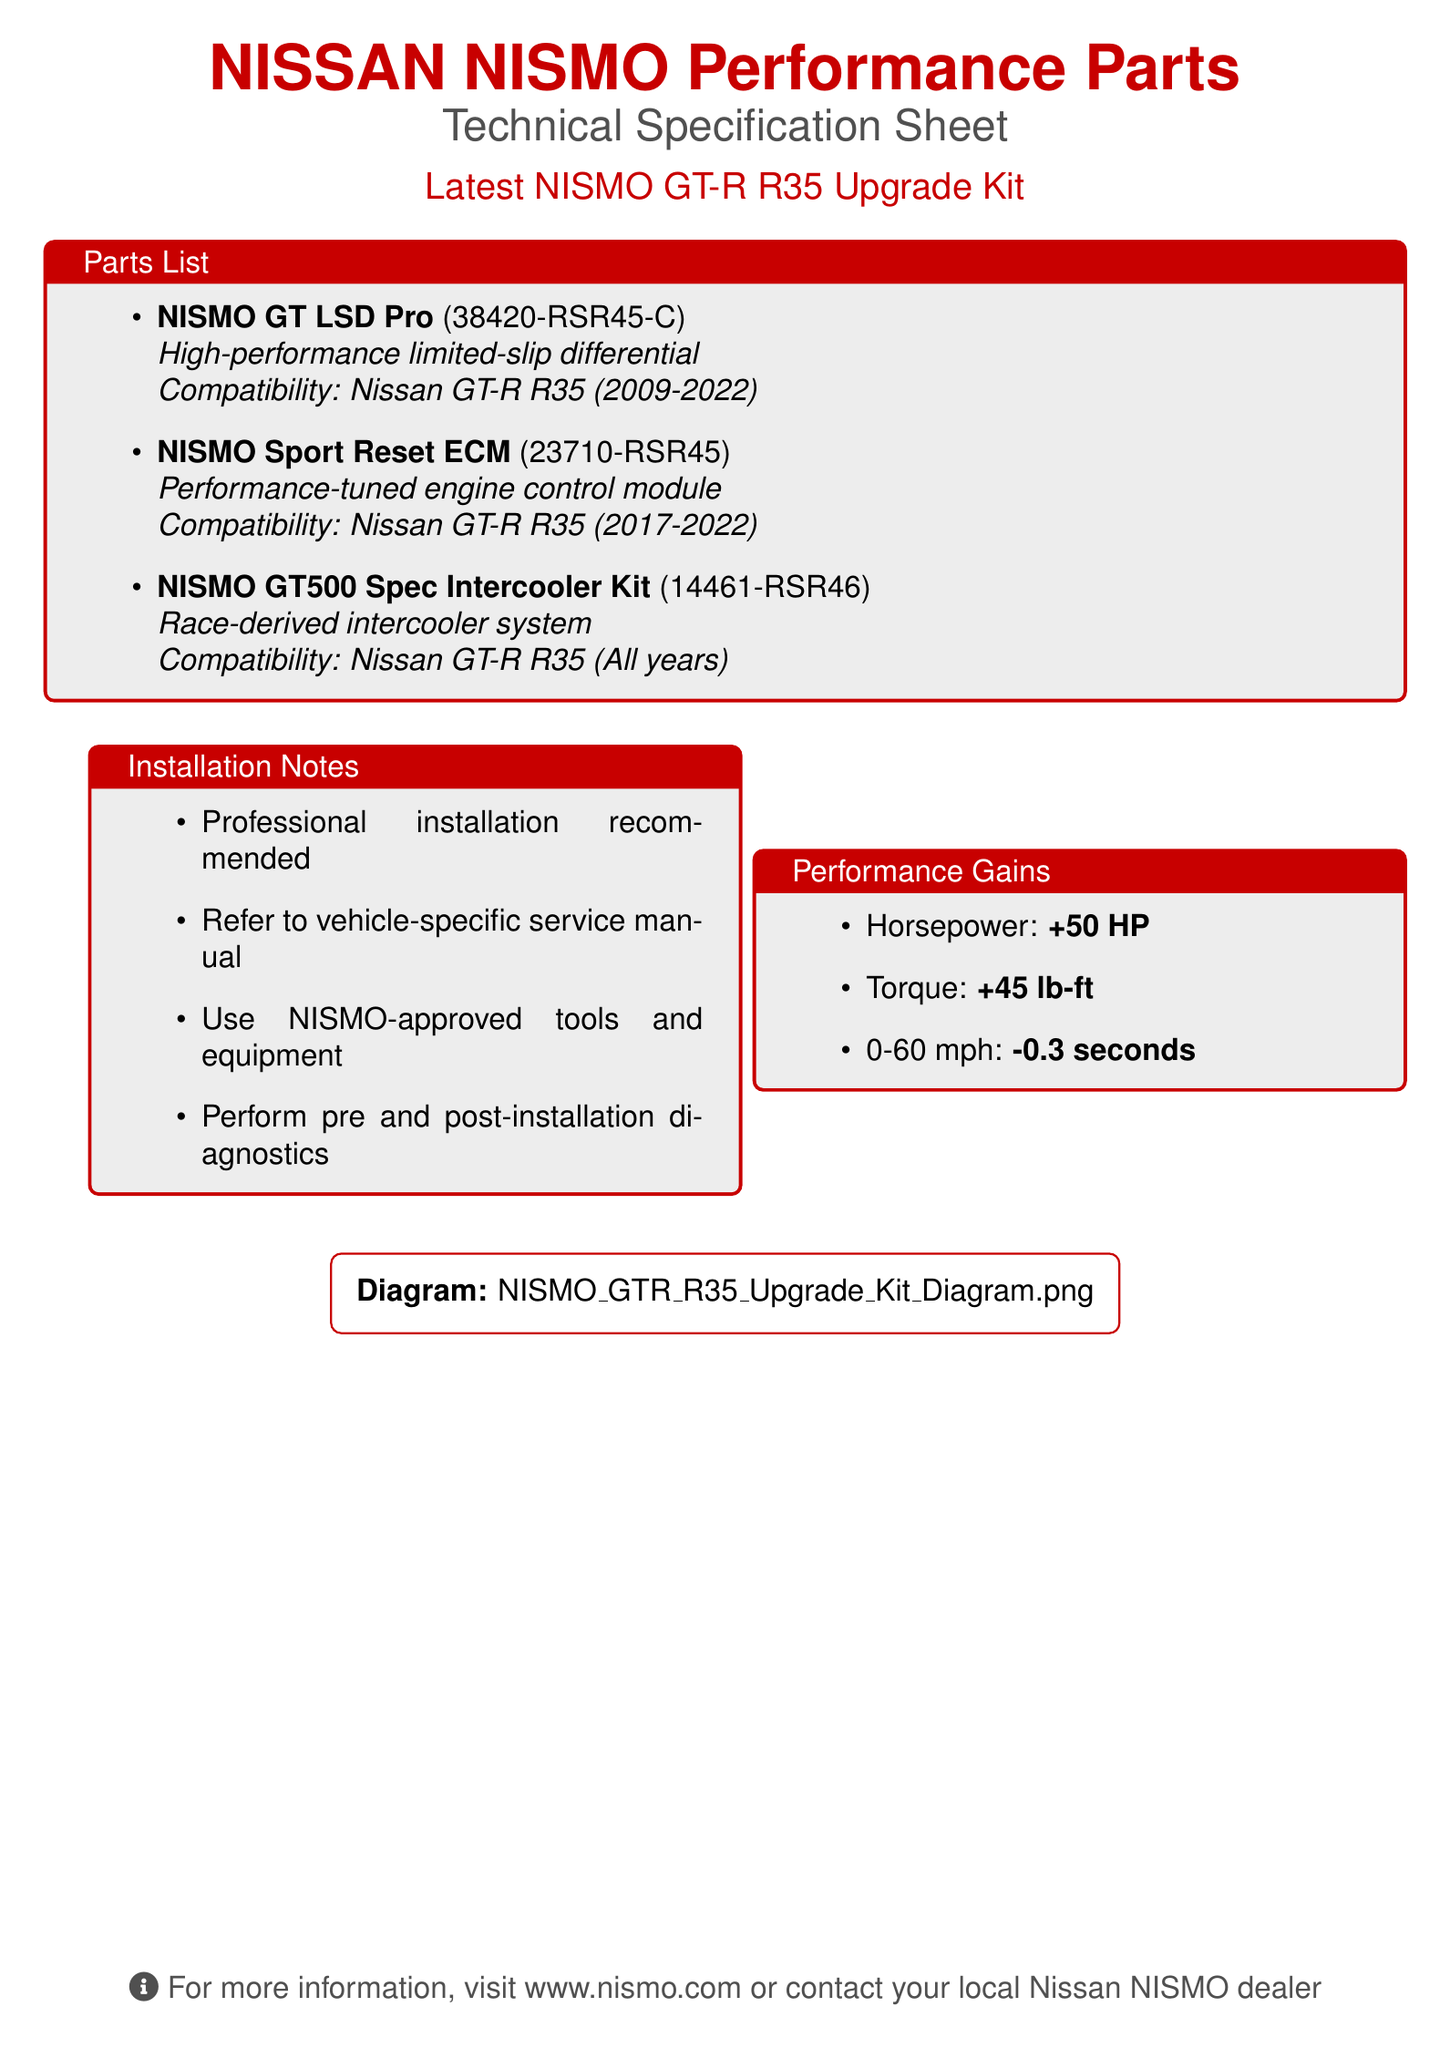What is the name of the performance parts kit? The document specifies the name of the kit as the "Latest NISMO GT-R R35 Upgrade Kit."
Answer: Latest NISMO GT-R R35 Upgrade Kit Which part is indicated as a high-performance limited-slip differential? The NISMO GT LSD Pro is identified as a high-performance limited-slip differential in the parts list.
Answer: NISMO GT LSD Pro What is the part number for the NISMO Sport Reset ECM? The NISMO Sport Reset ECM is listed with the part number 23710-RSR45.
Answer: 23710-RSR45 How much horsepower gain is provided by the upgrade kit? The performance gains section states that the upgrade kit provides a horsepower gain of +50 HP.
Answer: +50 HP What is the recommended installation type for the performance parts? The document notes that professional installation is recommended for the performance parts.
Answer: Professional installation How many pounds-feet of torque does the upgrade kit increase? The torque increase provided by the upgrade kit is detailed as +45 lb-ft in the performance gains section.
Answer: +45 lb-ft What year range does the NISMO GT LSD Pro support? The compatibility section specifies that the NISMO GT LSD Pro is compatible with the Nissan GT-R R35 from 2009 to 2022.
Answer: 2009-2022 What is noted as necessary prior to and after installation? The installation notes emphasize the need to perform pre and post-installation diagnostics.
Answer: Diagnostics What is the link for more information about NISMO performance parts? The document provides the web address for more information as www.nismo.com.
Answer: www.nismo.com 